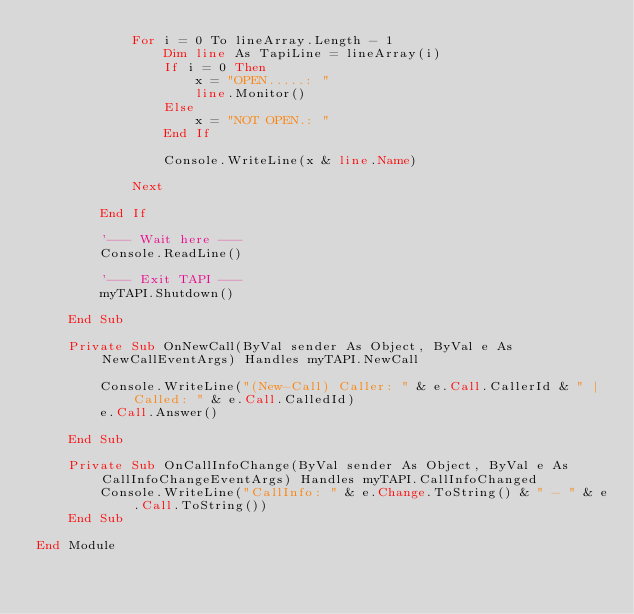<code> <loc_0><loc_0><loc_500><loc_500><_VisualBasic_>            For i = 0 To lineArray.Length - 1
                Dim line As TapiLine = lineArray(i)
                If i = 0 Then
                    x = "OPEN.....: "
                    line.Monitor()
                Else
                    x = "NOT OPEN.: "
                End If

                Console.WriteLine(x & line.Name)

            Next

        End If

        '--- Wait here ---
        Console.ReadLine()

        '--- Exit TAPI ---
        myTAPI.Shutdown()

    End Sub

    Private Sub OnNewCall(ByVal sender As Object, ByVal e As NewCallEventArgs) Handles myTAPI.NewCall

        Console.WriteLine("(New-Call) Caller: " & e.Call.CallerId & " | Called: " & e.Call.CalledId)
        e.Call.Answer()

    End Sub

    Private Sub OnCallInfoChange(ByVal sender As Object, ByVal e As CallInfoChangeEventArgs) Handles myTAPI.CallInfoChanged
        Console.WriteLine("CallInfo: " & e.Change.ToString() & " - " & e.Call.ToString())
    End Sub

End Module
</code> 